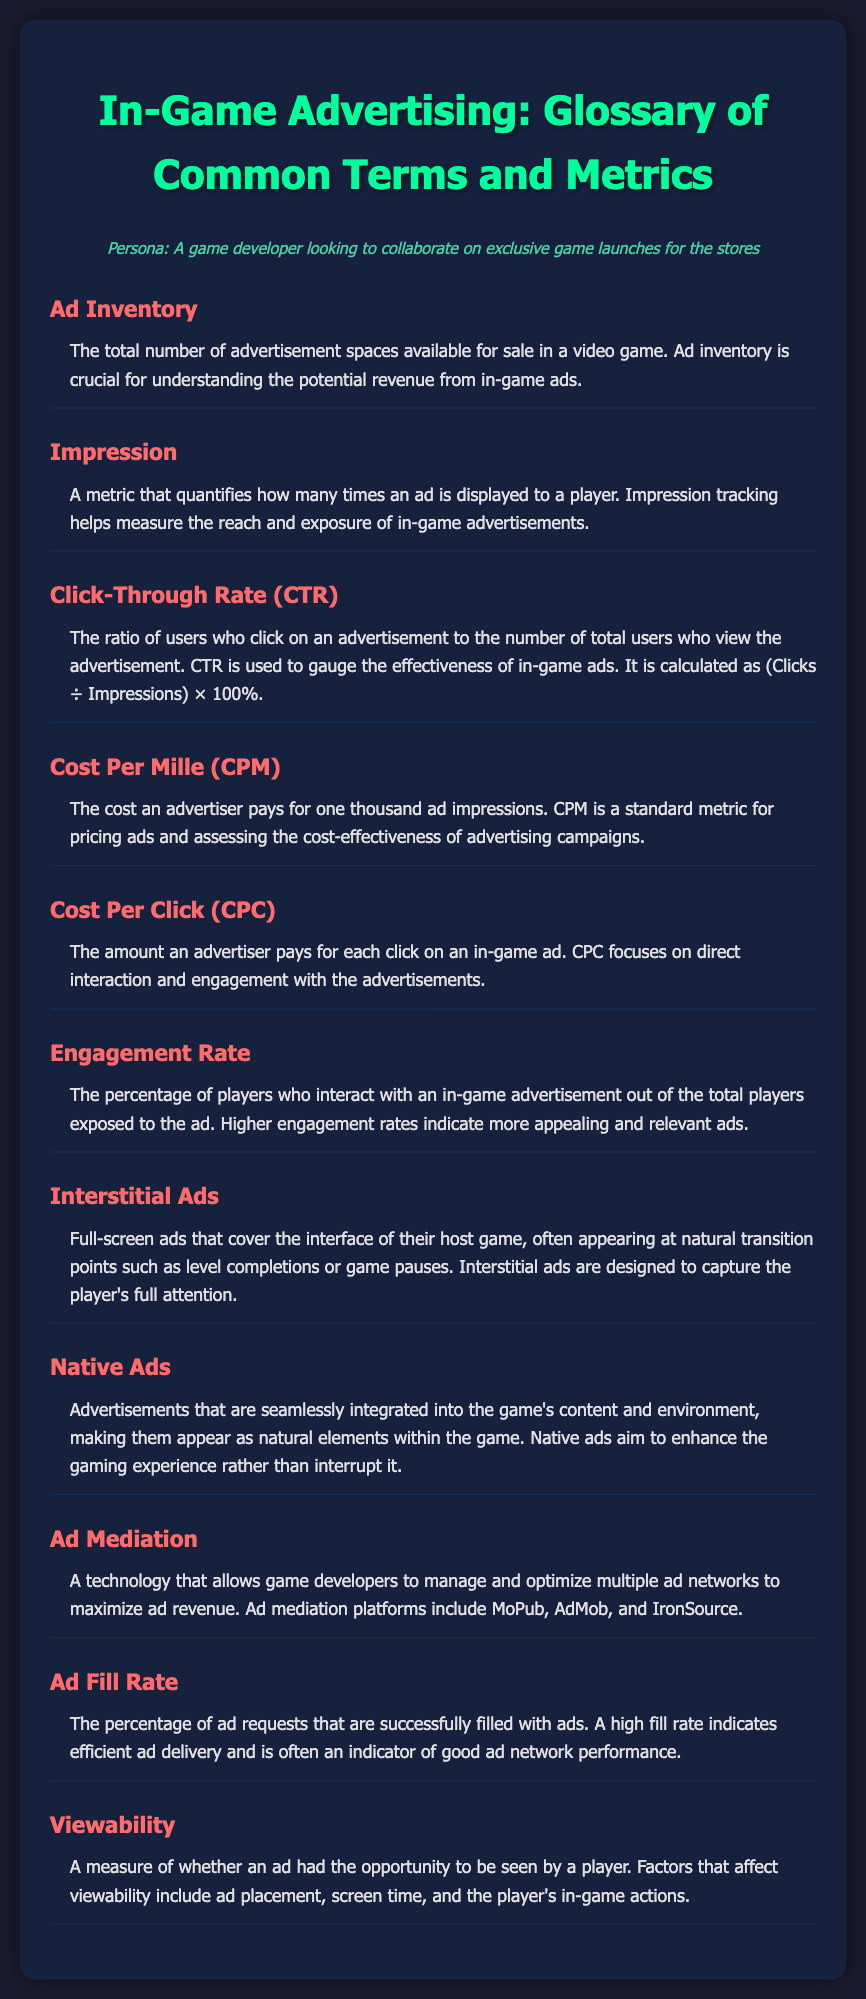What is Ad Inventory? Ad Inventory refers to the total number of advertisement spaces available for sale in a video game, essential for understanding potential revenue.
Answer: The total number of advertisement spaces available for sale in a video game What does CTR stand for? CTR stands for Click-Through Rate, a metric that measures the effectiveness of in-game ads.
Answer: Click-Through Rate What is the formula for Click-Through Rate (CTR)? CTR is calculated as (Clicks ÷ Impressions) × 100%.
Answer: (Clicks ÷ Impressions) × 100% What type of ads are Interstitial Ads? Interstitial Ads are full-screen ads that cover the interface of their host game.
Answer: Full-screen ads Define Cost Per Click (CPC). CPC is the amount an advertiser pays for each click on an in-game ad.
Answer: The amount an advertiser pays for each click on an in-game ad What does Viewability measure in in-game advertising? Viewability measures whether an ad had the opportunity to be seen by a player, influenced by various factors.
Answer: Whether an ad had the opportunity to be seen by a player What is Ad Mediation? Ad Mediation is a technology enabling game developers to manage and optimize multiple ad networks.
Answer: A technology that allows game developers to manage and optimize multiple ad networks What is the significance of Engagement Rate? Engagement Rate indicates the percentage of players interacting with an ad, reflecting its appeal.
Answer: The percentage of players who interact with an in-game advertisement What do Native Ads aim to do? Native Ads aim to enhance the gaming experience by being seamlessly integrated into the game.
Answer: Enhance the gaming experience 